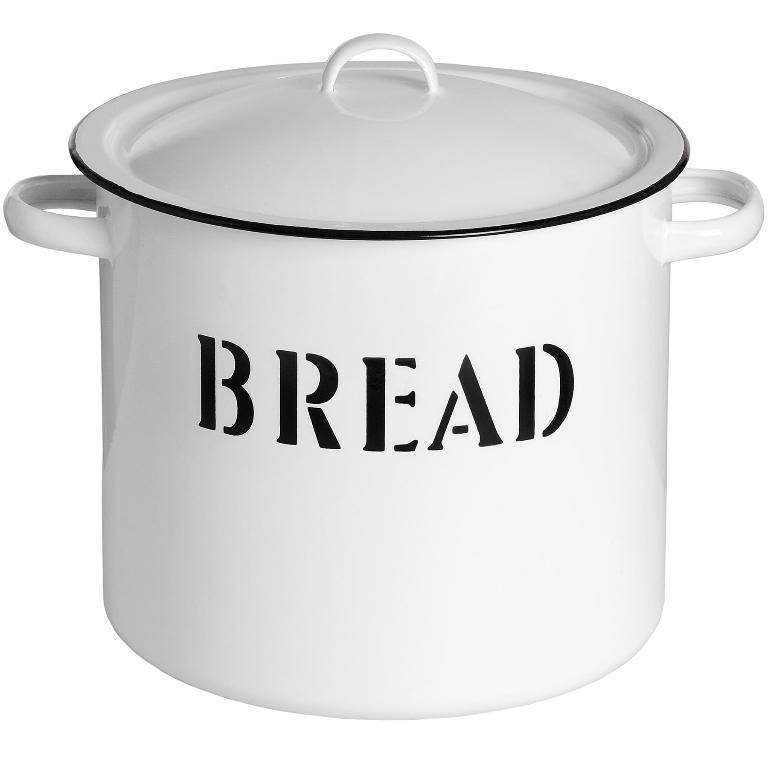Provide a one-sentence caption for the provided image. The large porcelain pot and lid were specifically designed and labelled for bread. 